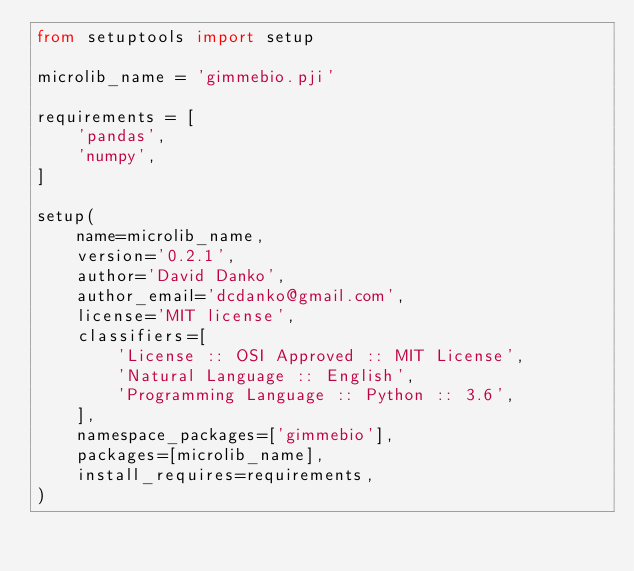Convert code to text. <code><loc_0><loc_0><loc_500><loc_500><_Python_>from setuptools import setup

microlib_name = 'gimmebio.pji'

requirements = [
    'pandas',
    'numpy',
]

setup(
    name=microlib_name,
    version='0.2.1',
    author='David Danko',
    author_email='dcdanko@gmail.com',
    license='MIT license',
    classifiers=[
        'License :: OSI Approved :: MIT License',
        'Natural Language :: English',
        'Programming Language :: Python :: 3.6',
    ],
    namespace_packages=['gimmebio'],
    packages=[microlib_name],
    install_requires=requirements,
)
</code> 